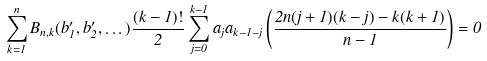<formula> <loc_0><loc_0><loc_500><loc_500>\sum _ { k = 1 } ^ { n } B _ { n , k } ( b _ { 1 } ^ { \prime } , b _ { 2 } ^ { \prime } , \dots ) \frac { ( k - 1 ) ! } { 2 } \sum _ { j = 0 } ^ { k - 1 } a _ { j } a _ { k - 1 - j } \left ( \frac { 2 n ( j + 1 ) ( k - j ) - k ( k + 1 ) } { n - 1 } \right ) = 0</formula> 